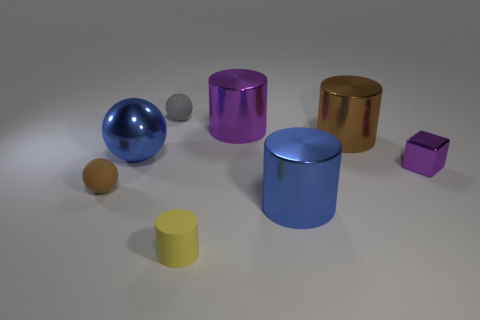Subtract 1 cylinders. How many cylinders are left? 3 Subtract all brown cylinders. How many cylinders are left? 3 Subtract all tiny yellow cylinders. How many cylinders are left? 3 Subtract all red cylinders. Subtract all cyan balls. How many cylinders are left? 4 Add 1 purple metallic blocks. How many objects exist? 9 Subtract all cubes. How many objects are left? 7 Add 7 small purple metal objects. How many small purple metal objects are left? 8 Add 1 small blue metallic cylinders. How many small blue metallic cylinders exist? 1 Subtract 0 green cylinders. How many objects are left? 8 Subtract all tiny gray objects. Subtract all small cylinders. How many objects are left? 6 